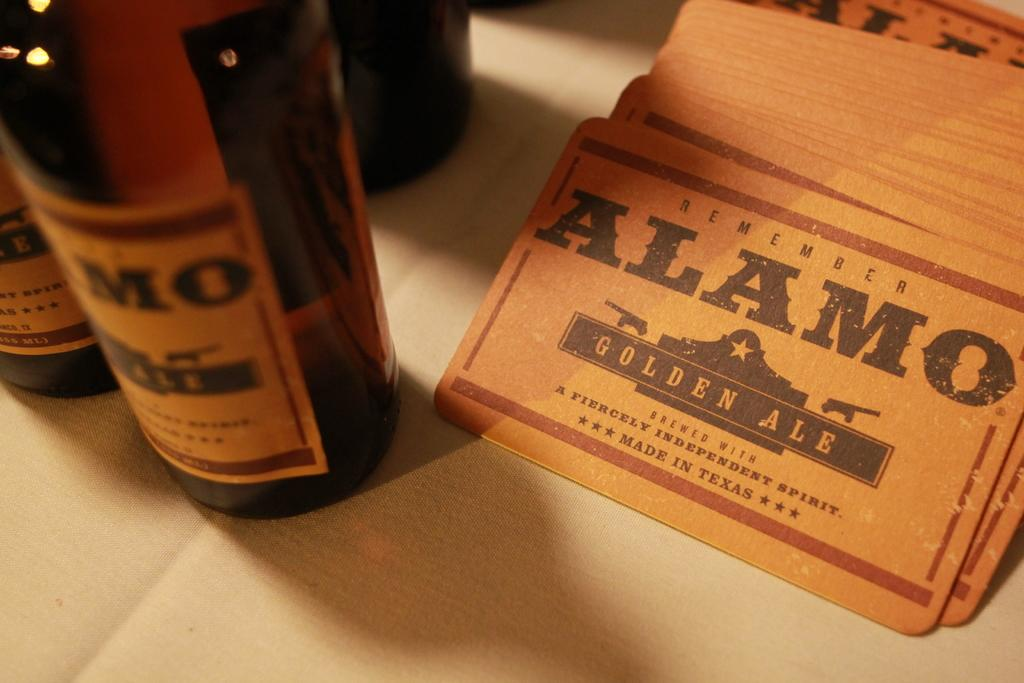What objects are on the surface in the image? There are carts and bottles on the surface in the image. What type of plant can be seen growing on the surface in the image? There is no plant visible on the surface in the image. What type of writing can be seen on the surface in the image? There is no writing visible on the surface in the image. What type of acoustics can be heard coming from the surface in the image? There is no sound or acoustics present in the image, as it is a static representation. 